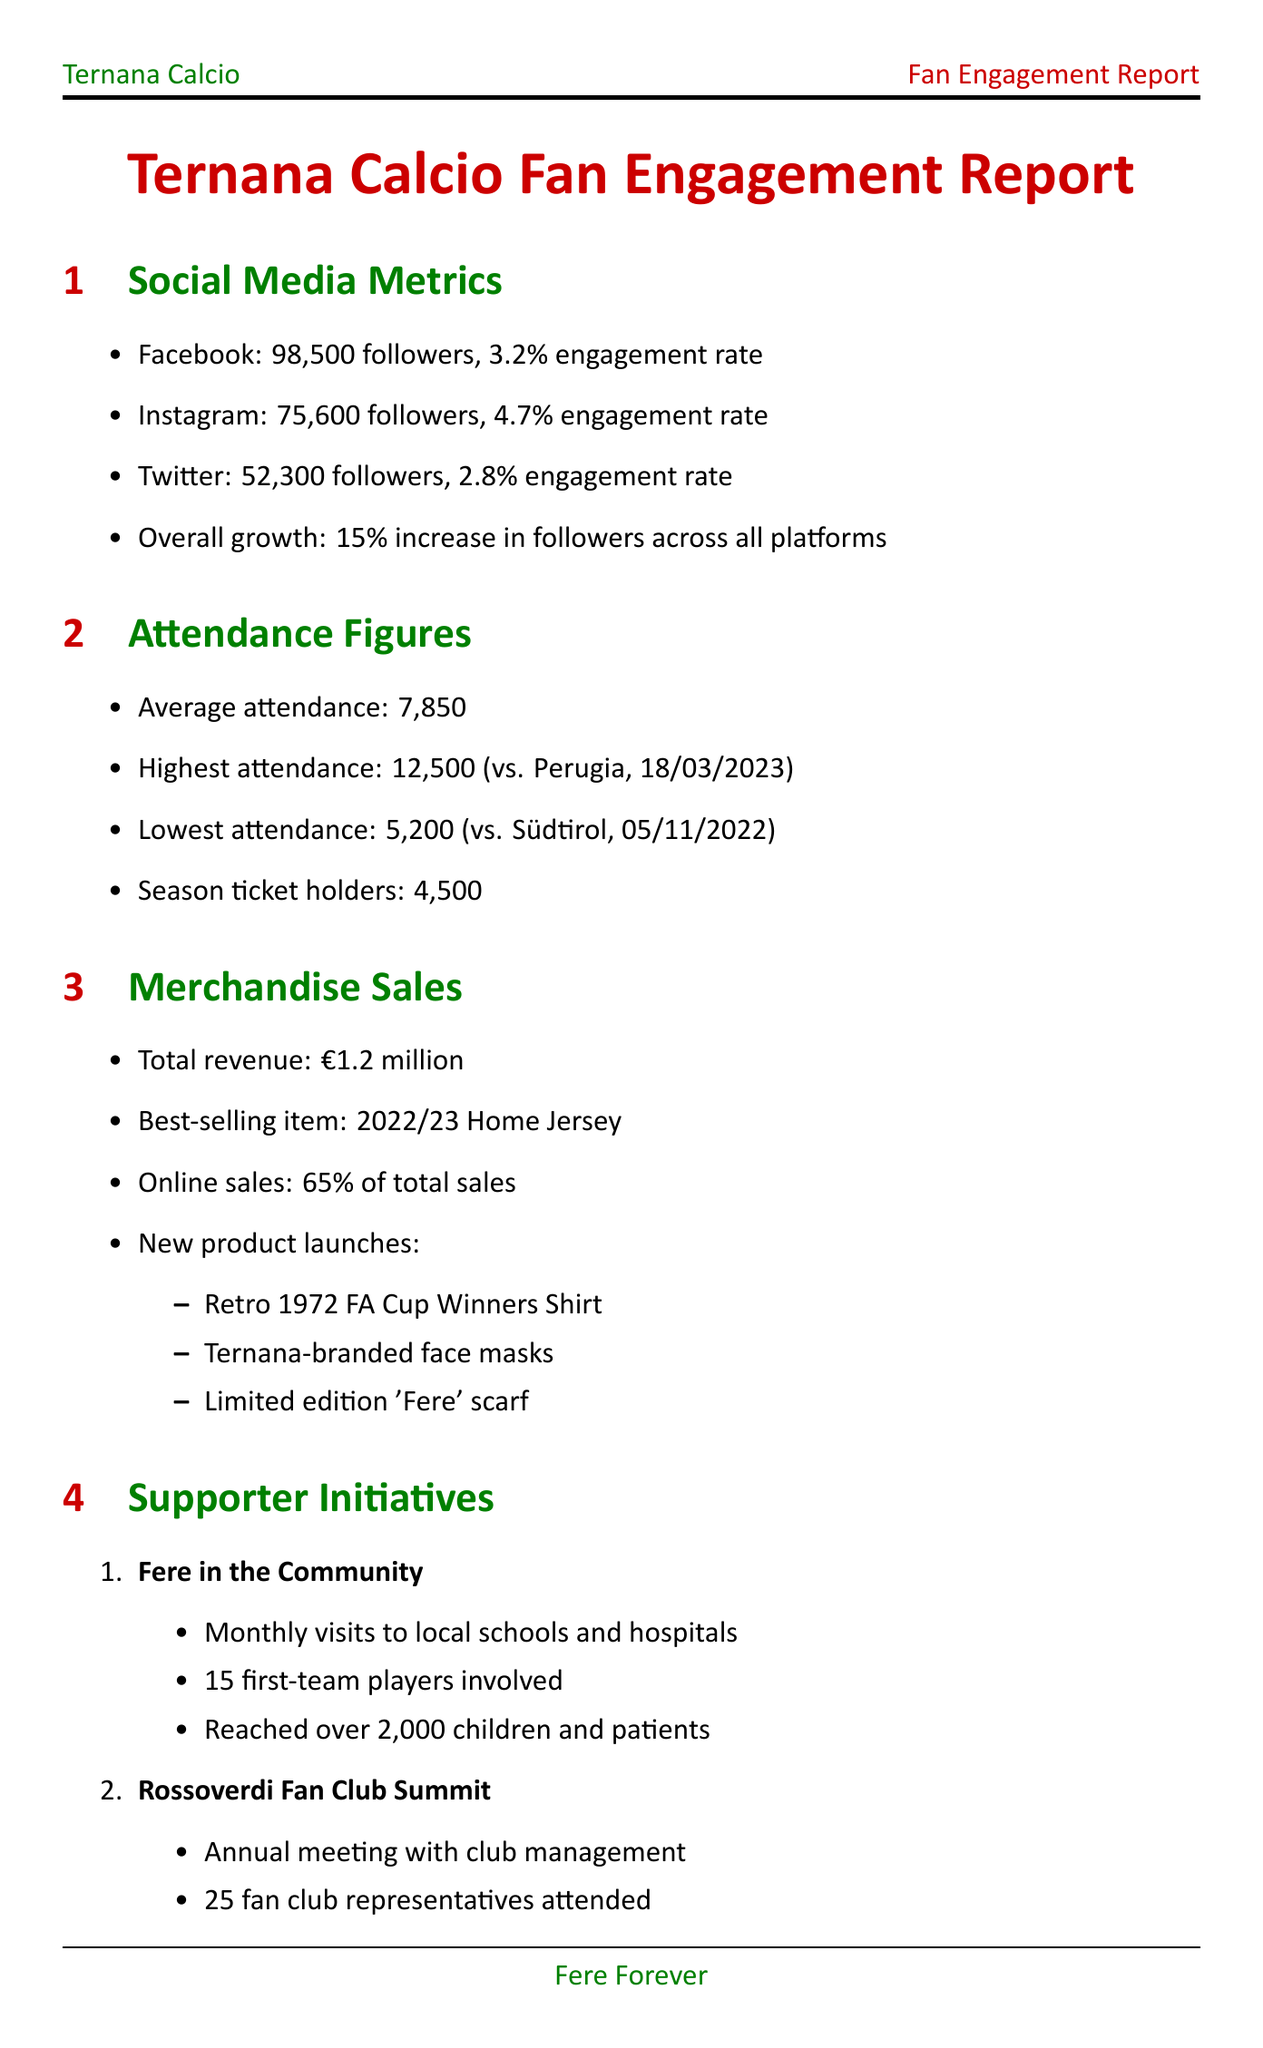what is the average attendance? The average attendance is stated under the attendance figures section of the document as 7,850.
Answer: 7,850 what is the best-selling merchandise item? The document specifies that the best-selling item is the 2022/23 Home Jersey.
Answer: 2022/23 Home Jersey how many followers does Ternana have on Instagram? The number of Instagram followers is listed as 75,600 in the social media metrics section.
Answer: 75,600 what is the expected launch date of the Fere Fan Zone? The Fere Fan Zone's expected launch date is found in the future initiatives section as August 2023.
Answer: August 2023 how many first-team players are involved in the "Fere in the Community" initiative? The number of first-team players involved in this initiative is mentioned as 15 in the supporter initiatives section.
Answer: 15 what is the overall satisfaction rating from the fan feedback survey? The overall satisfaction rating is provided in the survey results, which is 7.8.
Answer: 7.8 what was the highest attendance figure recorded for a match? The highest attendance figure is recorded as 12,500 for the match against Perugia on March 18, 2023.
Answer: 12,500 how many representatives attended the Rossoverdi Fan Club Summit? The document states that representatives from 25 fan clubs attended the summit.
Answer: 25 what percentage of merchandise sales were from online sales? The percentage of online sales from merchandise is stated as 65% in the merchandise sales section.
Answer: 65% 